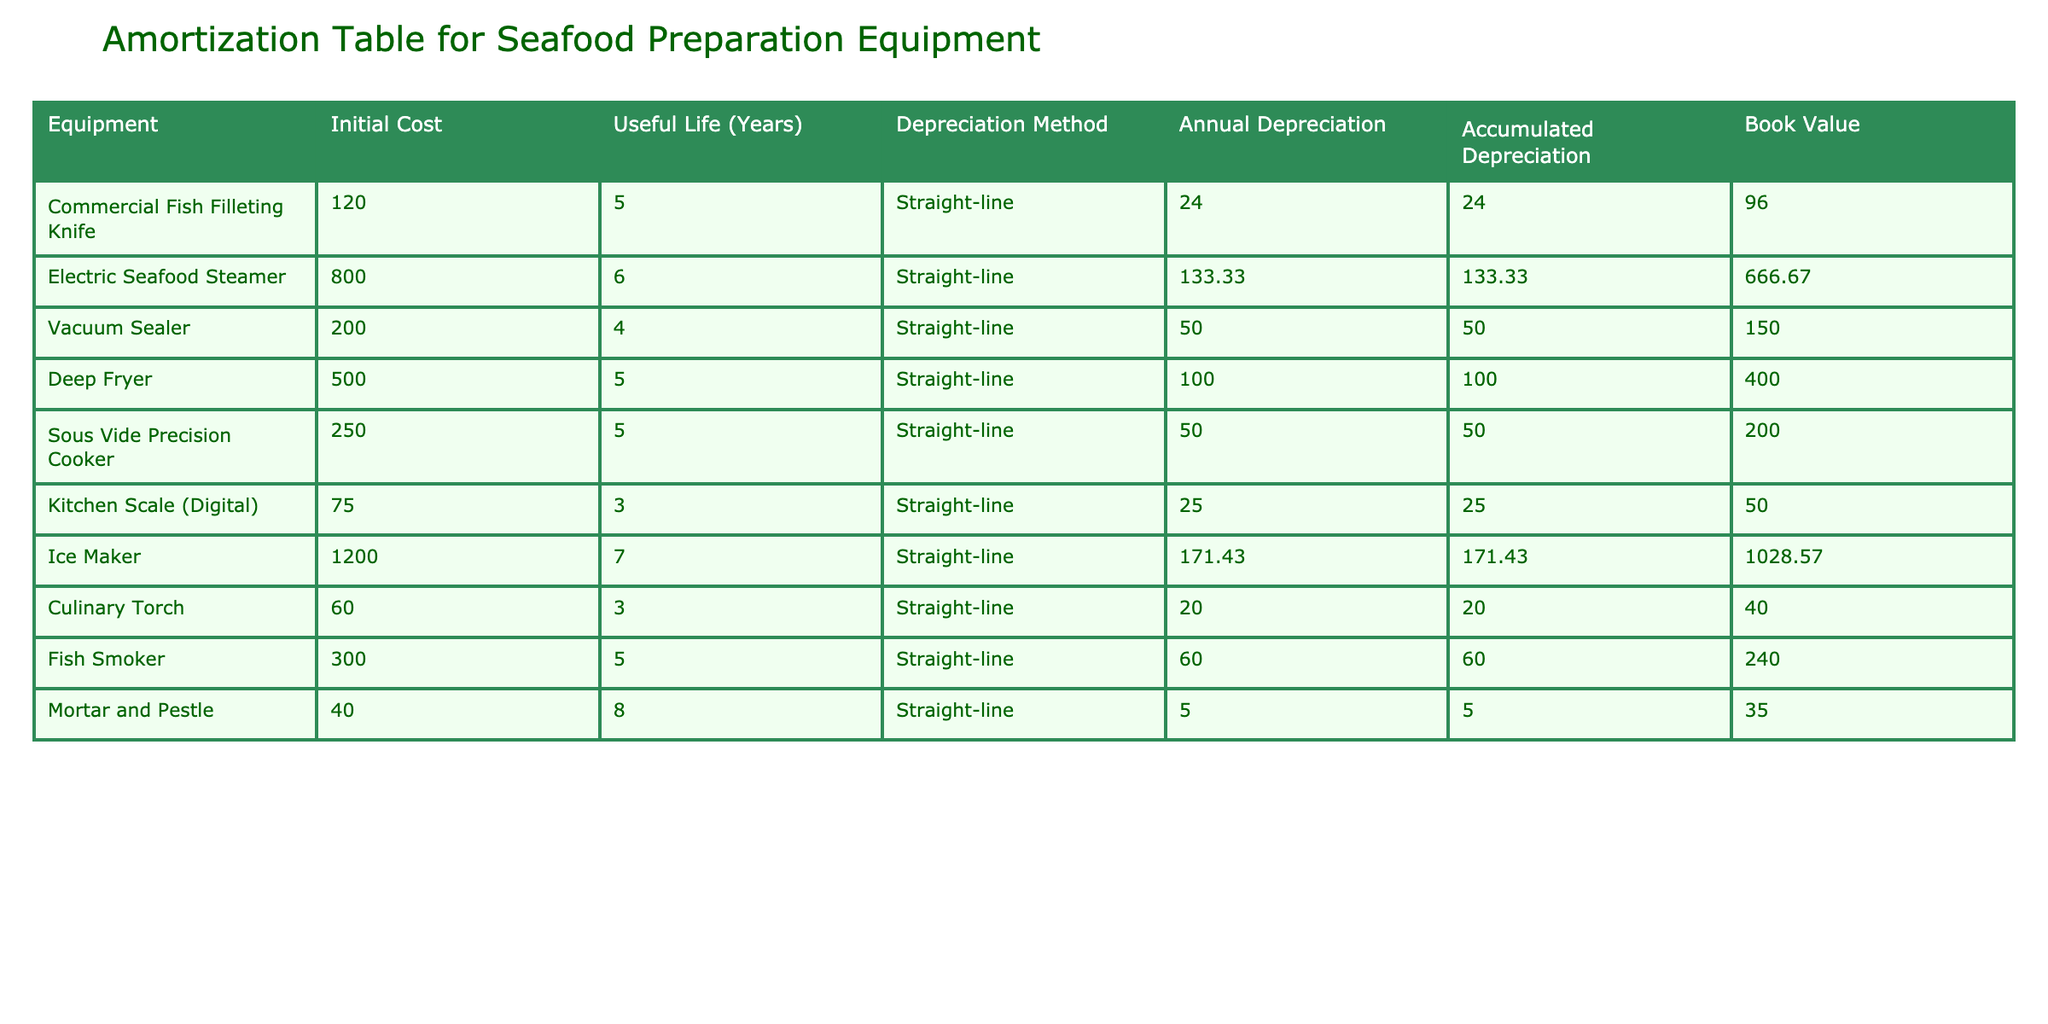What is the initial cost of the Electric Seafood Steamer? From the table, I can directly find the row for the Electric Seafood Steamer. It shows that the initial cost is listed as 800.00.
Answer: 800.00 What is the accumulated depreciation for the Commercial Fish Filleting Knife? By looking at the row for the Commercial Fish Filleting Knife in the table, I can see that the accumulated depreciation is reported as 24.00.
Answer: 24.00 Which kitchen appliance has the highest annual depreciation? Analyzing the 'Annual Depreciation' column, I compare the values: 24.00, 133.33, 50.00, 100.00, 50.00, 25.00, 171.43, 20.00, 60.00, 5.00. The highest value is 171.43 for the Ice Maker.
Answer: Ice Maker What is the total accumulated depreciation for all kitchen appliances? To find the total accumulated depreciation, sum all the values in the 'Accumulated Depreciation' column: 24.00 + 133.33 + 50.00 + 100.00 + 50.00 + 25.00 + 171.43 + 20.00 + 60.00 + 5.00 equals  1,082.76.
Answer: 1,082.76 Is the book value of the Deep Fryer more than 300.00? Checking the row for the Deep Fryer, the book value is listed as 400.00. Since 400.00 is greater than 300.00, the answer is yes.
Answer: Yes What is the average annual depreciation of all kitchen appliances? First, I add up all the annual depreciation values: 24.00 + 133.33 + 50.00 + 100.00 + 50.00 + 25.00 + 171.43 + 20.00 + 60.00 + 5.00 equals  615.76. Next, I divide by the total number of appliances, which is 10, giving an average of 61.58.
Answer: 61.58 Does the Mortar and Pestle have a useful life of more than 5 years? By looking at the row for the Mortar and Pestle, it shows a useful life of 8 years, which is indeed more than 5 years.
Answer: Yes Which appliance has the lowest book value? Reviewing the 'Book Value' column: 96.00, 666.67, 150.00, 400.00, 200.00, 50.00, 1028.57, 40.00, 240.00, 35.00, the lowest value is 35.00 for the Mortar and Pestle.
Answer: Mortar and Pestle 